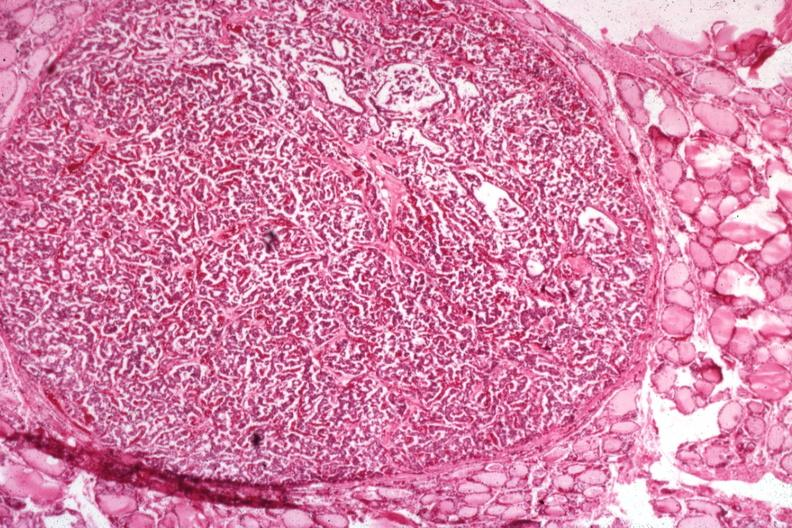s endocrine present?
Answer the question using a single word or phrase. Yes 